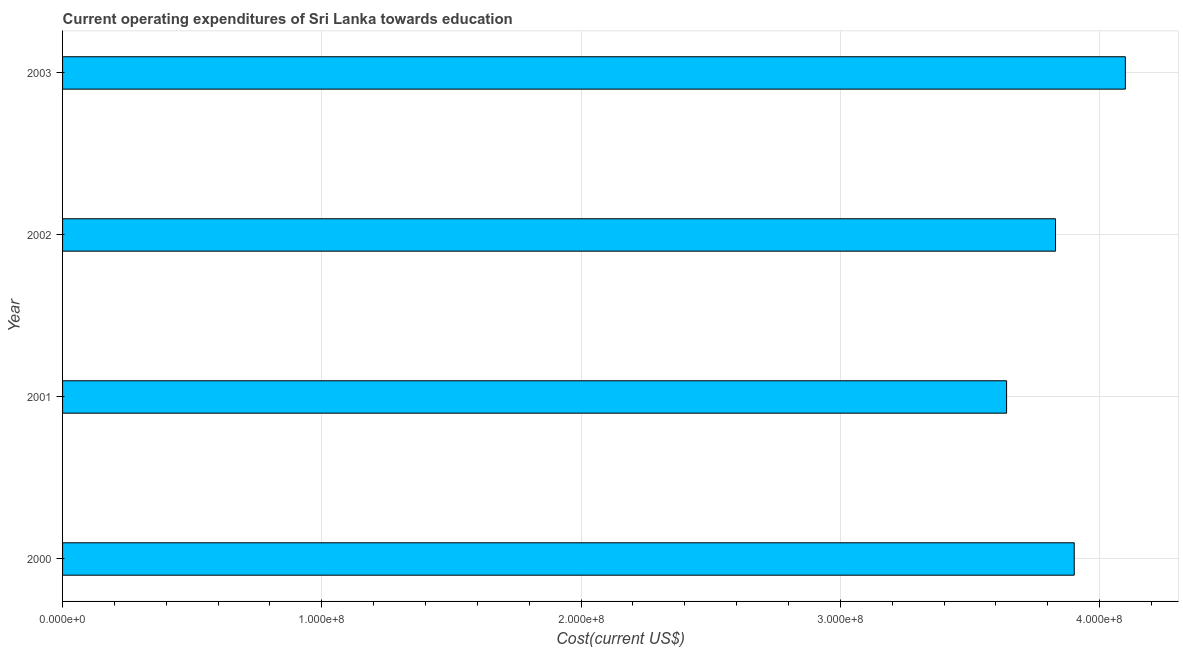Does the graph contain grids?
Keep it short and to the point. Yes. What is the title of the graph?
Offer a very short reply. Current operating expenditures of Sri Lanka towards education. What is the label or title of the X-axis?
Make the answer very short. Cost(current US$). What is the label or title of the Y-axis?
Your response must be concise. Year. What is the education expenditure in 2000?
Provide a short and direct response. 3.90e+08. Across all years, what is the maximum education expenditure?
Ensure brevity in your answer.  4.10e+08. Across all years, what is the minimum education expenditure?
Your answer should be very brief. 3.64e+08. In which year was the education expenditure maximum?
Your answer should be compact. 2003. In which year was the education expenditure minimum?
Give a very brief answer. 2001. What is the sum of the education expenditure?
Provide a short and direct response. 1.55e+09. What is the difference between the education expenditure in 2002 and 2003?
Your answer should be very brief. -2.69e+07. What is the average education expenditure per year?
Offer a terse response. 3.87e+08. What is the median education expenditure?
Give a very brief answer. 3.87e+08. In how many years, is the education expenditure greater than 340000000 US$?
Your answer should be very brief. 4. Do a majority of the years between 2002 and 2001 (inclusive) have education expenditure greater than 220000000 US$?
Make the answer very short. No. Is the education expenditure in 2002 less than that in 2003?
Your answer should be very brief. Yes. Is the difference between the education expenditure in 2001 and 2003 greater than the difference between any two years?
Give a very brief answer. Yes. What is the difference between the highest and the second highest education expenditure?
Provide a succinct answer. 1.97e+07. Is the sum of the education expenditure in 2000 and 2002 greater than the maximum education expenditure across all years?
Your answer should be very brief. Yes. What is the difference between the highest and the lowest education expenditure?
Give a very brief answer. 4.58e+07. In how many years, is the education expenditure greater than the average education expenditure taken over all years?
Offer a terse response. 2. How many bars are there?
Keep it short and to the point. 4. How many years are there in the graph?
Provide a succinct answer. 4. Are the values on the major ticks of X-axis written in scientific E-notation?
Offer a terse response. Yes. What is the Cost(current US$) of 2000?
Give a very brief answer. 3.90e+08. What is the Cost(current US$) in 2001?
Keep it short and to the point. 3.64e+08. What is the Cost(current US$) in 2002?
Make the answer very short. 3.83e+08. What is the Cost(current US$) in 2003?
Give a very brief answer. 4.10e+08. What is the difference between the Cost(current US$) in 2000 and 2001?
Give a very brief answer. 2.61e+07. What is the difference between the Cost(current US$) in 2000 and 2002?
Give a very brief answer. 7.23e+06. What is the difference between the Cost(current US$) in 2000 and 2003?
Your response must be concise. -1.97e+07. What is the difference between the Cost(current US$) in 2001 and 2002?
Your answer should be very brief. -1.89e+07. What is the difference between the Cost(current US$) in 2001 and 2003?
Ensure brevity in your answer.  -4.58e+07. What is the difference between the Cost(current US$) in 2002 and 2003?
Keep it short and to the point. -2.69e+07. What is the ratio of the Cost(current US$) in 2000 to that in 2001?
Your response must be concise. 1.07. What is the ratio of the Cost(current US$) in 2001 to that in 2002?
Offer a very short reply. 0.95. What is the ratio of the Cost(current US$) in 2001 to that in 2003?
Offer a very short reply. 0.89. What is the ratio of the Cost(current US$) in 2002 to that in 2003?
Keep it short and to the point. 0.93. 